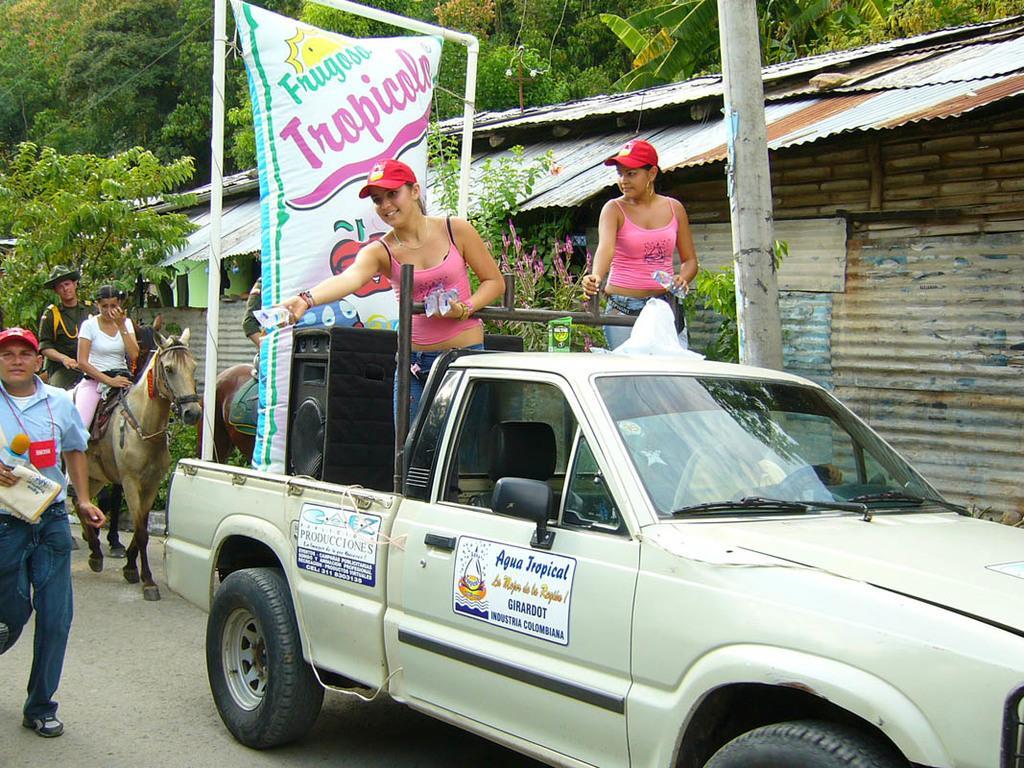Describe this image in one or two sentences. In this picture there is a vehicle on the right side of the image, there is a poster and a speaker in the vehicle, there are two girls on the right side of the image, in the car and there is a horse and people on the left side of the image, there are trees and a shed at the top side of the image. 